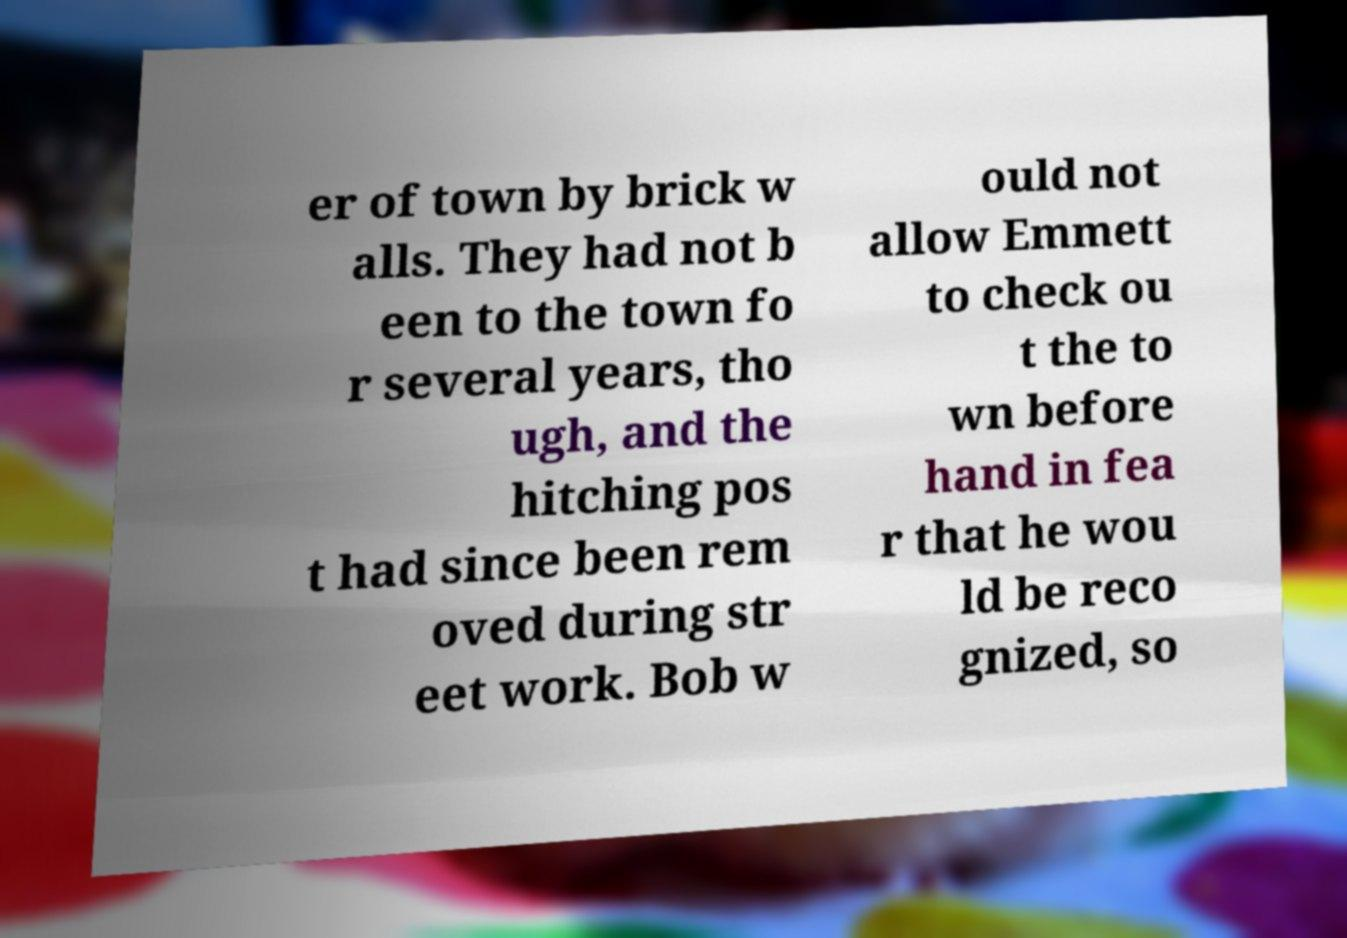I need the written content from this picture converted into text. Can you do that? er of town by brick w alls. They had not b een to the town fo r several years, tho ugh, and the hitching pos t had since been rem oved during str eet work. Bob w ould not allow Emmett to check ou t the to wn before hand in fea r that he wou ld be reco gnized, so 